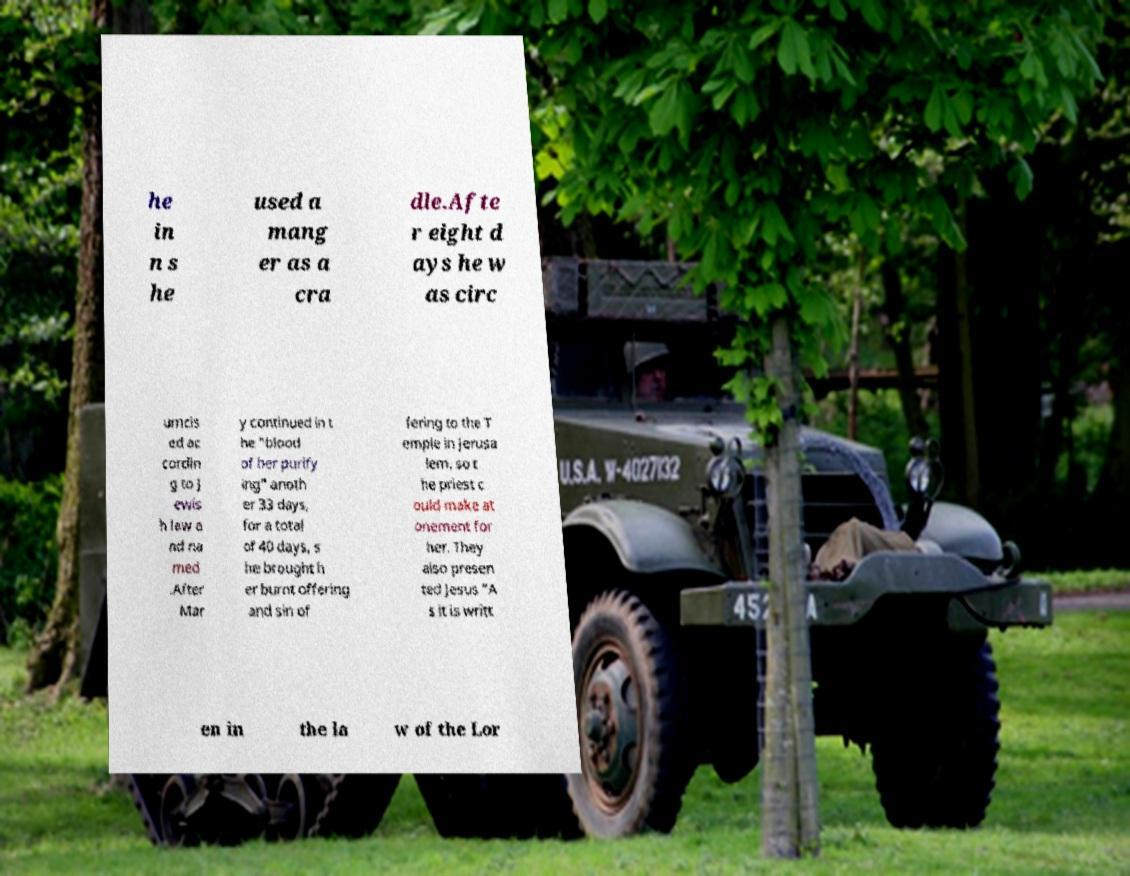I need the written content from this picture converted into text. Can you do that? he in n s he used a mang er as a cra dle.Afte r eight d ays he w as circ umcis ed ac cordin g to J ewis h law a nd na med .After Mar y continued in t he "blood of her purify ing" anoth er 33 days, for a total of 40 days, s he brought h er burnt offering and sin of fering to the T emple in Jerusa lem, so t he priest c ould make at onement for her. They also presen ted Jesus "A s it is writt en in the la w of the Lor 